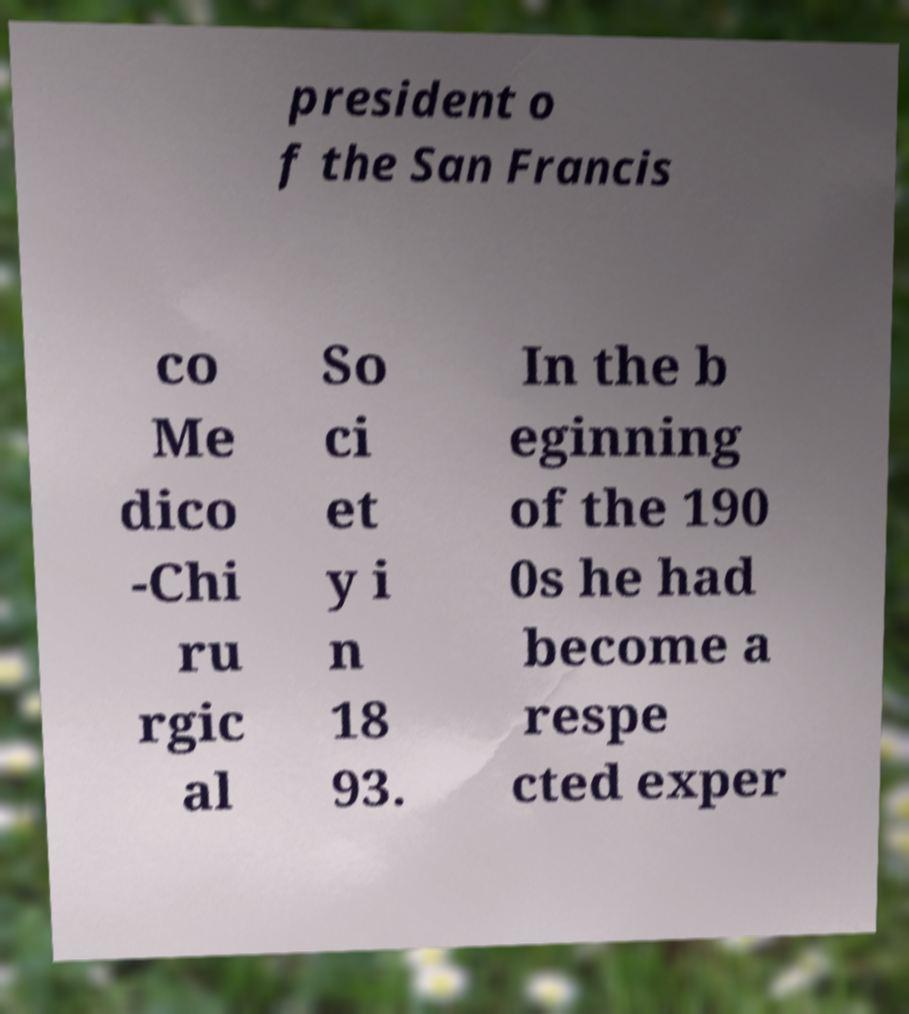Please read and relay the text visible in this image. What does it say? president o f the San Francis co Me dico -Chi ru rgic al So ci et y i n 18 93. In the b eginning of the 190 0s he had become a respe cted exper 